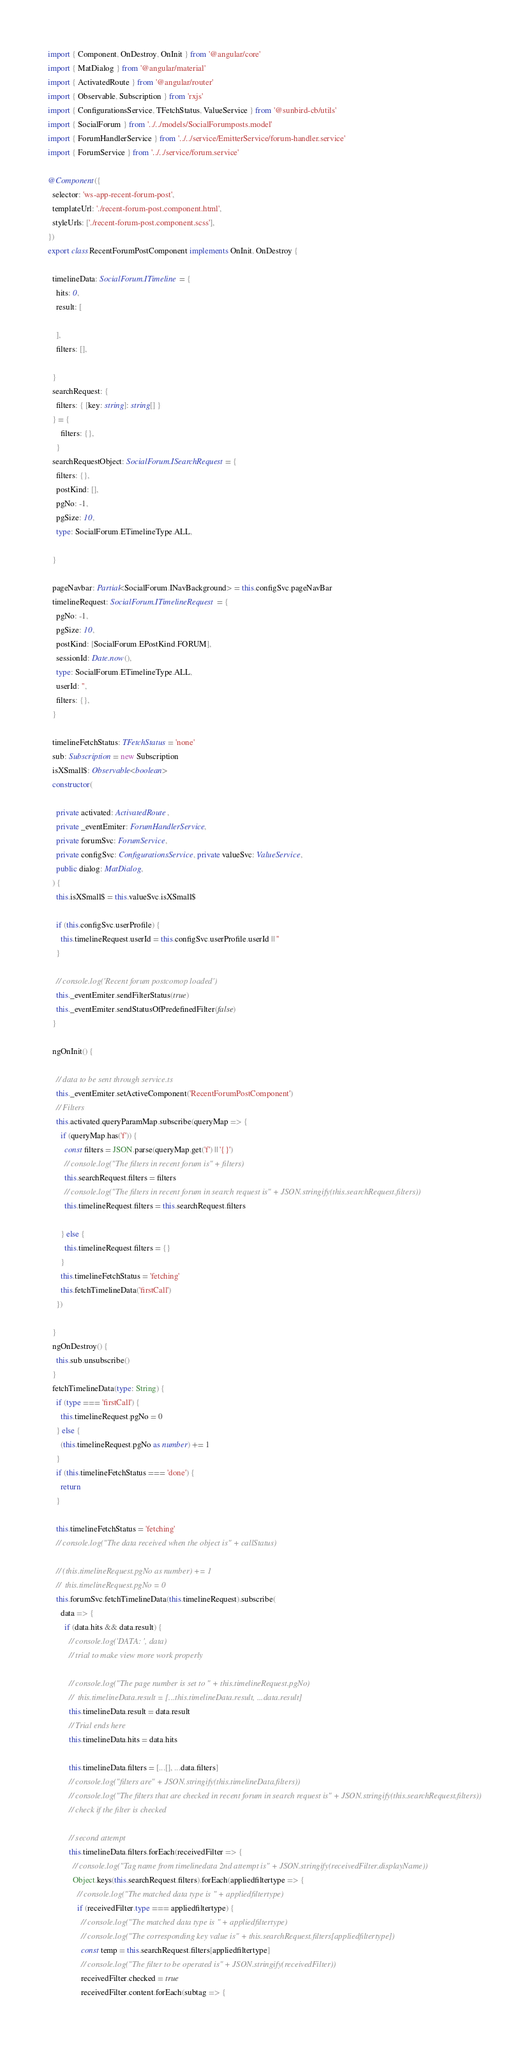Convert code to text. <code><loc_0><loc_0><loc_500><loc_500><_TypeScript_>import { Component, OnDestroy, OnInit } from '@angular/core'
import { MatDialog } from '@angular/material'
import { ActivatedRoute } from '@angular/router'
import { Observable, Subscription } from 'rxjs'
import { ConfigurationsService, TFetchStatus, ValueService } from '@sunbird-cb/utils'
import { SocialForum } from '../../models/SocialForumposts.model'
import { ForumHandlerService } from '../../service/EmitterService/forum-handler.service'
import { ForumService } from '../../service/forum.service'

@Component({
  selector: 'ws-app-recent-forum-post',
  templateUrl: './recent-forum-post.component.html',
  styleUrls: ['./recent-forum-post.component.scss'],
})
export class RecentForumPostComponent implements OnInit, OnDestroy {

  timelineData: SocialForum.ITimeline = {
    hits: 0,
    result: [

    ],
    filters: [],

  }
  searchRequest: {
    filters: { [key: string]: string[] }
  } = {
      filters: {},
    }
  searchRequestObject: SocialForum.ISearchRequest = {
    filters: {},
    postKind: [],
    pgNo: -1,
    pgSize: 10,
    type: SocialForum.ETimelineType.ALL,

  }

  pageNavbar: Partial<SocialForum.INavBackground> = this.configSvc.pageNavBar
  timelineRequest: SocialForum.ITimelineRequest = {
    pgNo: -1,
    pgSize: 10,
    postKind: [SocialForum.EPostKind.FORUM],
    sessionId: Date.now(),
    type: SocialForum.ETimelineType.ALL,
    userId: '',
    filters: {},
  }

  timelineFetchStatus: TFetchStatus = 'none'
  sub: Subscription = new Subscription
  isXSmall$: Observable<boolean>
  constructor(

    private activated: ActivatedRoute,
    private _eventEmiter: ForumHandlerService,
    private forumSvc: ForumService,
    private configSvc: ConfigurationsService, private valueSvc: ValueService,
    public dialog: MatDialog,
  ) {
    this.isXSmall$ = this.valueSvc.isXSmall$

    if (this.configSvc.userProfile) {
      this.timelineRequest.userId = this.configSvc.userProfile.userId || ''
    }

    // console.log('Recent forum postcomop loaded')
    this._eventEmiter.sendFilterStatus(true)
    this._eventEmiter.sendStatusOfPredefinedFilter(false)
  }

  ngOnInit() {

    // data to be sent through service.ts
    this._eventEmiter.setActiveComponent('RecentForumPostComponent')
    // Filters
    this.activated.queryParamMap.subscribe(queryMap => {
      if (queryMap.has('f')) {
        const filters = JSON.parse(queryMap.get('f') || '{}')
        // console.log("The filters in recent forum is" + filters)
        this.searchRequest.filters = filters
        // console.log("The filters in recent forum in search request is" + JSON.stringify(this.searchRequest.filters))
        this.timelineRequest.filters = this.searchRequest.filters

      } else {
        this.timelineRequest.filters = {}
      }
      this.timelineFetchStatus = 'fetching'
      this.fetchTimelineData('firstCall')
    })

  }
  ngOnDestroy() {
    this.sub.unsubscribe()
  }
  fetchTimelineData(type: String) {
    if (type === 'firstCall') {
      this.timelineRequest.pgNo = 0
    } else {
      (this.timelineRequest.pgNo as number) += 1
    }
    if (this.timelineFetchStatus === 'done') {
      return
    }

    this.timelineFetchStatus = 'fetching'
    // console.log("The data received when the object is" + callStatus)

    // (this.timelineRequest.pgNo as number) += 1
    //  this.timelineRequest.pgNo = 0
    this.forumSvc.fetchTimelineData(this.timelineRequest).subscribe(
      data => {
        if (data.hits && data.result) {
          // console.log('DATA: ', data)
          // trial to make view more work properly

          // console.log("The page number is set to " + this.timelineRequest.pgNo)
          //  this.timelineData.result = [...this.timelineData.result, ...data.result]
          this.timelineData.result = data.result
          // Trial ends here
          this.timelineData.hits = data.hits

          this.timelineData.filters = [...[], ...data.filters]
          // console.log("filters are" + JSON.stringify(this.timelineData.filters))
          // console.log("The filters that are checked in recent forum in search request is" + JSON.stringify(this.searchRequest.filters))
          // check if the filter is checked

          // second attempt
          this.timelineData.filters.forEach(receivedFilter => {
            // console.log("Tag name from timelinedata 2nd attempt is" + JSON.stringify(receivedFilter.displayName))
            Object.keys(this.searchRequest.filters).forEach(appliedfiltertype => {
              // console.log("The matched data type is " + appliedfiltertype)
              if (receivedFilter.type === appliedfiltertype) {
                // console.log("The matched data type is " + appliedfiltertype)
                // console.log("The corresponding key value is" + this.searchRequest.filters[appliedfiltertype])
                const temp = this.searchRequest.filters[appliedfiltertype]
                // console.log("The filter to be operated is" + JSON.stringify(receivedFilter))
                receivedFilter.checked = true
                receivedFilter.content.forEach(subtag => {</code> 